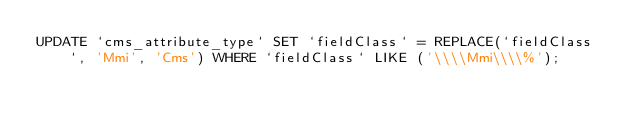Convert code to text. <code><loc_0><loc_0><loc_500><loc_500><_SQL_>UPDATE `cms_attribute_type` SET `fieldClass` = REPLACE(`fieldClass`, 'Mmi', 'Cms') WHERE `fieldClass` LIKE ('\\\\Mmi\\\\%');</code> 